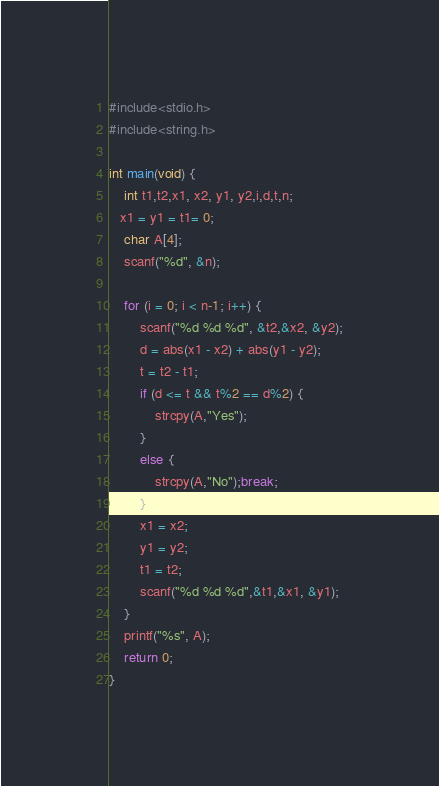Convert code to text. <code><loc_0><loc_0><loc_500><loc_500><_C_>#include<stdio.h>
#include<string.h>

int main(void) {
	int t1,t2,x1, x2, y1, y2,i,d,t,n;
   x1 = y1 = t1= 0;
	char A[4];
	scanf("%d", &n);
	
	for (i = 0; i < n-1; i++) {
		scanf("%d %d %d", &t2,&x2, &y2);
		d = abs(x1 - x2) + abs(y1 - y2);
		t = t2 - t1;
		if (d <= t && t%2 == d%2) {
			strcpy(A,"Yes");
		}
		else {
			strcpy(A,"No");break;
		}
		x1 = x2;
		y1 = y2;
        t1 = t2;
      	scanf("%d %d %d",&t1,&x1, &y1);
	}
	printf("%s", A);
	return 0;
}</code> 